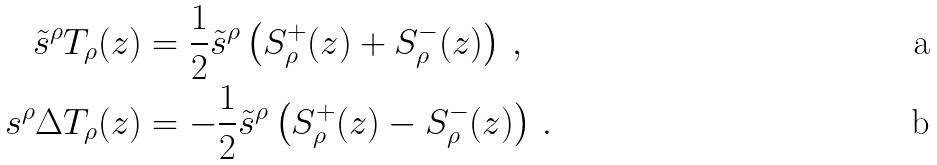Convert formula to latex. <formula><loc_0><loc_0><loc_500><loc_500>\tilde { s } ^ { \rho } T _ { \rho } ( { z } ) & = \frac { 1 } { 2 } \tilde { s } ^ { \rho } \left ( S ^ { + } _ { \rho } ( { z } ) + S ^ { - } _ { \rho } ( { z } ) \right ) \, , \\ s ^ { \rho } \Delta T _ { \rho } ( { z } ) & = - \frac { 1 } { 2 } \tilde { s } ^ { \rho } \left ( S ^ { + } _ { \rho } ( { z } ) - S ^ { - } _ { \rho } ( { z } ) \right ) \, .</formula> 